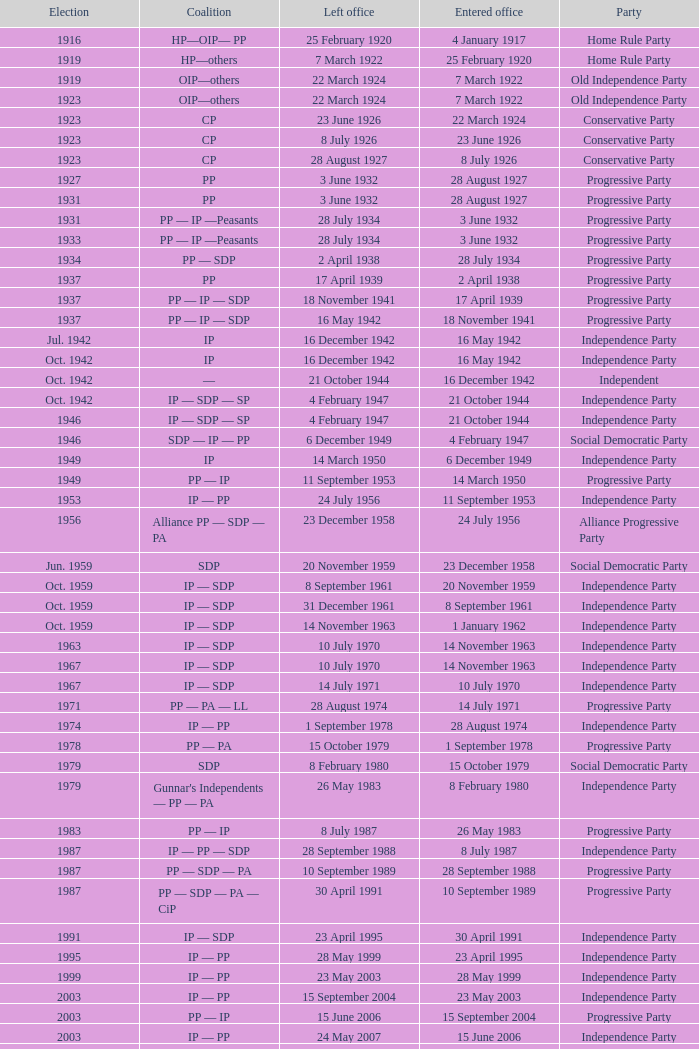When did the party elected in jun. 1959 enter office? 23 December 1958. 